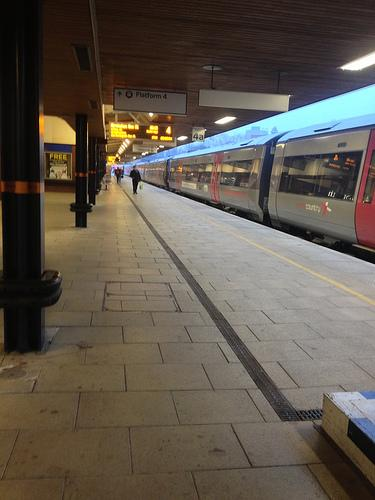In the image, what element separates the platform from the train tracks? A yellow line painted on the tile of the train terminal separates the platform from the train tracks. What material covers the ground in the train terminal? The ground in the train terminal is covered with tile flooring. Using the available information, give a brief summary of the scene. This scene takes place in a train station with people waiting for the train on a platform, numerous signs providing information, and a red and white train along the tracks. In a short sentence, describe the appearance of the subway train. The train appears to be red and white, with windows on the sides. Describe one visible activity being performed by a person in the image. A person is walking along the train platform. How are the available bus routes displayed in this scene? The bus routes are displayed on a sign hanging from the ceiling in the terminal. What can be inferred about the vicinity based on the image information? The vicinity appears to be a busy train station with various signs and people waiting for the train. Mention one structural detail of the train terminal's ceiling. The ceiling of the train terminal is made of wooden slats. Identify the main mode of transportation depicted in this image. The main mode of transportation in this image is a train. List three objects found in the image and their general color. A sign with platform 4 written on it (white), the platform (beige), and a red and white train. 